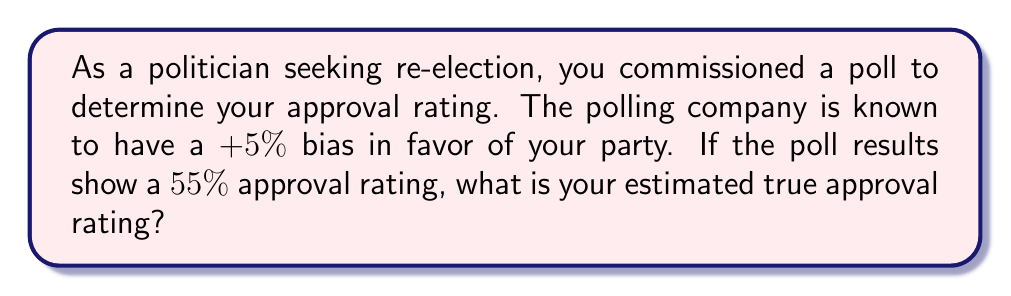Solve this math problem. To estimate the true approval rating from biased polling results, we need to account for the known bias in the polling process. Let's approach this step-by-step:

1. Given information:
   - Reported approval rating: 55%
   - Known bias: +5% in favor of your party

2. The bias indicates that the reported result is 5 percentage points higher than the true value. To correct for this, we need to subtract the bias from the reported value.

3. Calculate the estimated true approval rating:
   $$\text{True Approval Rating} = \text{Reported Approval Rating} - \text{Bias}$$
   $$\text{True Approval Rating} = 55\% - 5\%$$
   $$\text{True Approval Rating} = 50\%$$

4. Therefore, the estimated true approval rating is 50%.

This approach assumes a simple additive bias model. In more complex scenarios, other factors such as sampling methods, demographic weightings, and non-response bias might need to be considered for a more accurate estimation.
Answer: 50% 